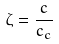<formula> <loc_0><loc_0><loc_500><loc_500>\zeta = \frac { c } { c _ { c } }</formula> 